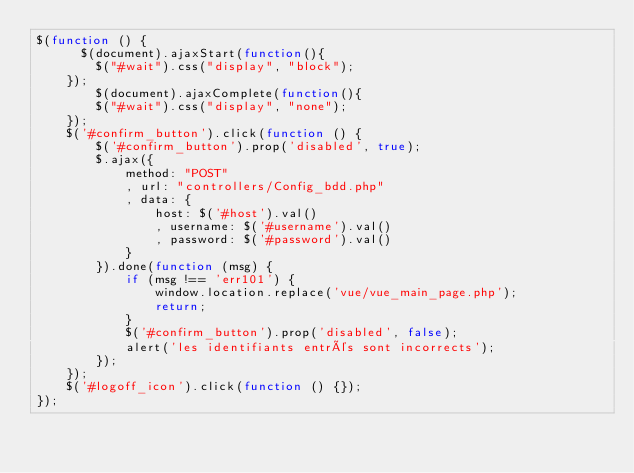Convert code to text. <code><loc_0><loc_0><loc_500><loc_500><_JavaScript_>$(function () {
      $(document).ajaxStart(function(){
        $("#wait").css("display", "block");
    });
        $(document).ajaxComplete(function(){
        $("#wait").css("display", "none");
    });
    $('#confirm_button').click(function () {
        $('#confirm_button').prop('disabled', true);
        $.ajax({
            method: "POST"
            , url: "controllers/Config_bdd.php"
            , data: {
                host: $('#host').val()
                , username: $('#username').val()
                , password: $('#password').val()
            }
        }).done(function (msg) {
            if (msg !== 'err101') {
                window.location.replace('vue/vue_main_page.php');
                return;
            }
            $('#confirm_button').prop('disabled', false);
            alert('les identifiants entrés sont incorrects');
        });
    });
    $('#logoff_icon').click(function () {});
});</code> 